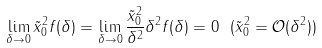<formula> <loc_0><loc_0><loc_500><loc_500>\lim _ { \delta \rightarrow 0 } \tilde { x } _ { 0 } ^ { 2 } f ( \delta ) = \lim _ { \delta \rightarrow 0 } \frac { \tilde { x } _ { 0 } ^ { 2 } } { \delta ^ { 2 } } \delta ^ { 2 } f ( \delta ) = 0 \ ( \tilde { x } _ { 0 } ^ { 2 } = { \mathcal { O } } ( \delta ^ { 2 } ) )</formula> 